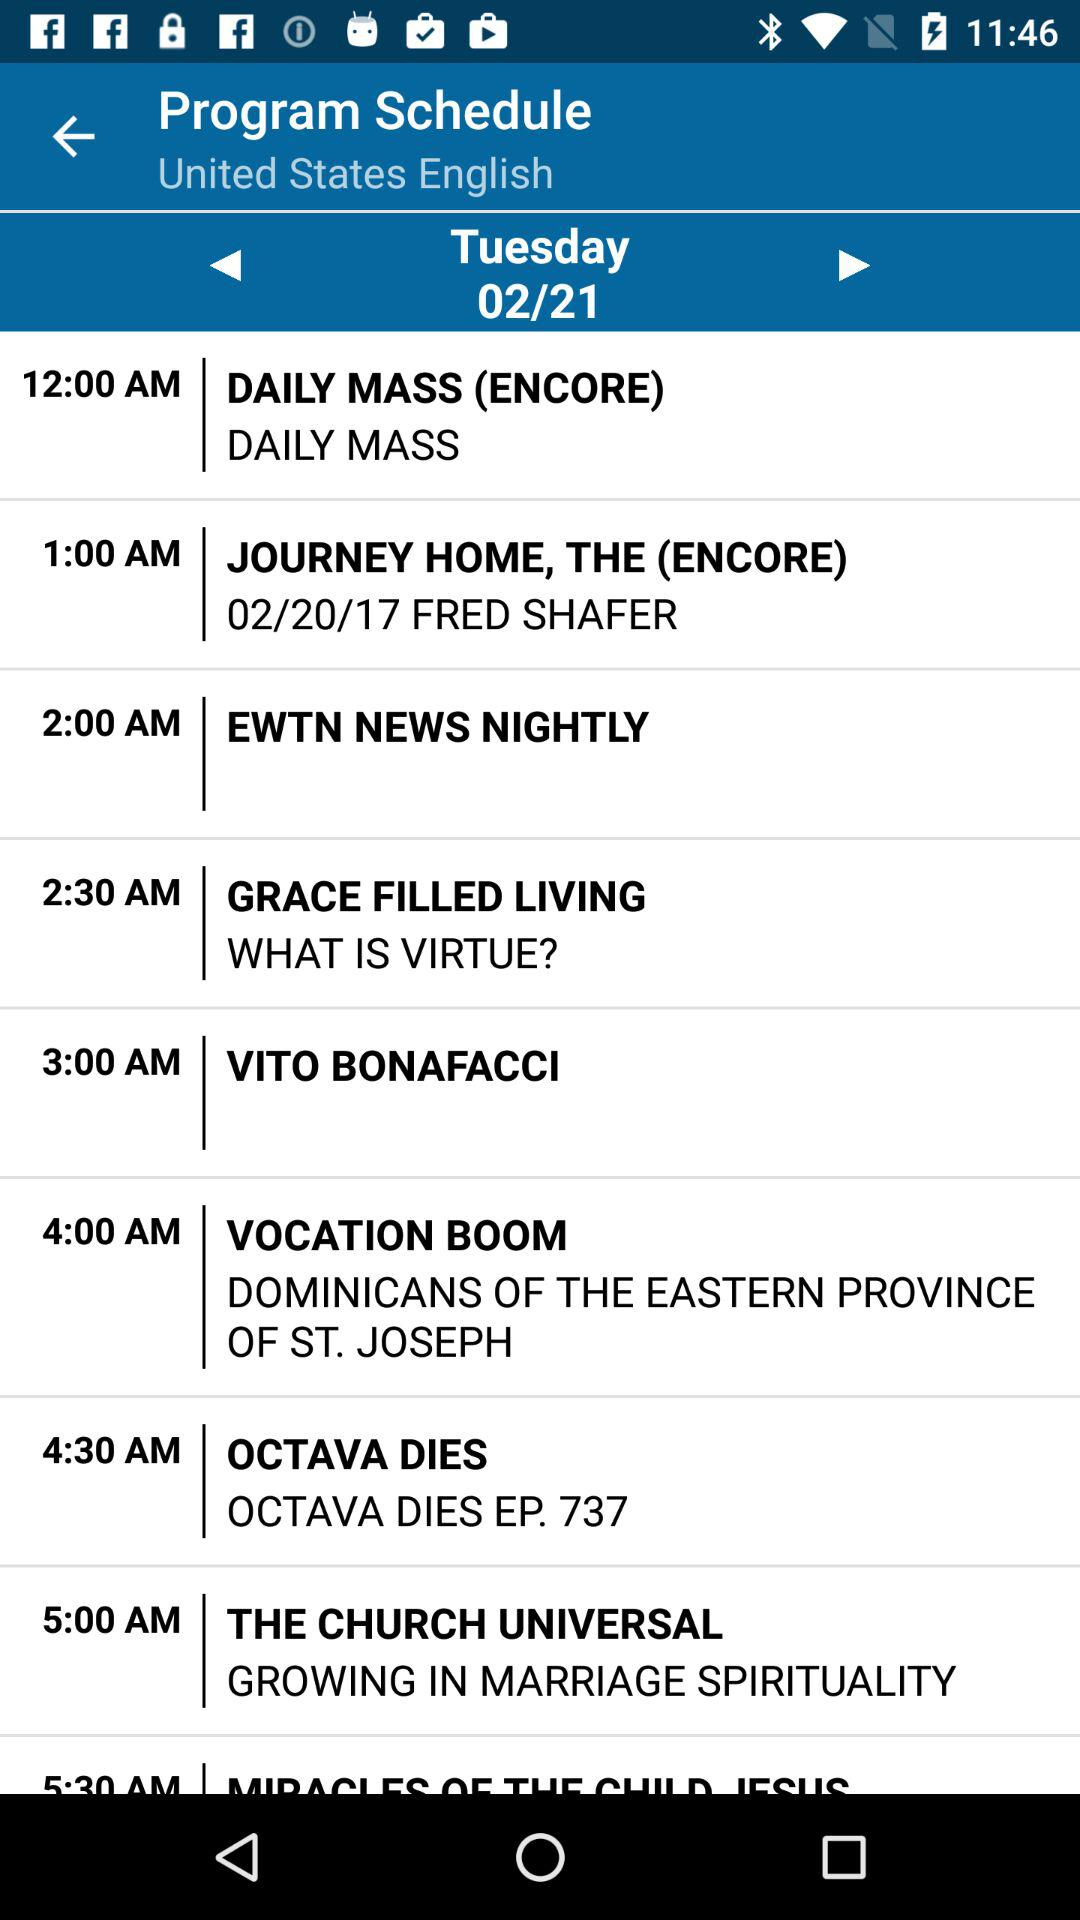What is the selected date? The selected date is Tuesday, February 21. 